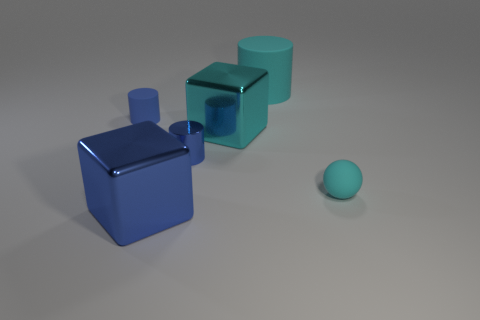There is a big blue metallic thing; does it have the same shape as the large shiny object that is behind the blue shiny block?
Give a very brief answer. Yes. Is the number of tiny blue metal cylinders that are in front of the tiny cyan rubber thing less than the number of blue shiny objects left of the blue metallic cylinder?
Ensure brevity in your answer.  Yes. Are there any other things that are the same shape as the big cyan metallic thing?
Keep it short and to the point. Yes. Does the large cyan shiny thing have the same shape as the big blue shiny thing?
Make the answer very short. Yes. What is the size of the cyan cylinder?
Keep it short and to the point. Large. There is a matte object that is both left of the small cyan rubber sphere and in front of the large matte object; what is its color?
Your response must be concise. Blue. Are there more objects than big things?
Offer a very short reply. Yes. How many objects are cyan matte objects or big blocks in front of the cyan rubber sphere?
Keep it short and to the point. 3. Does the cyan metallic thing have the same size as the blue matte thing?
Offer a very short reply. No. Are there any tiny blue things in front of the small blue matte thing?
Offer a very short reply. Yes. 